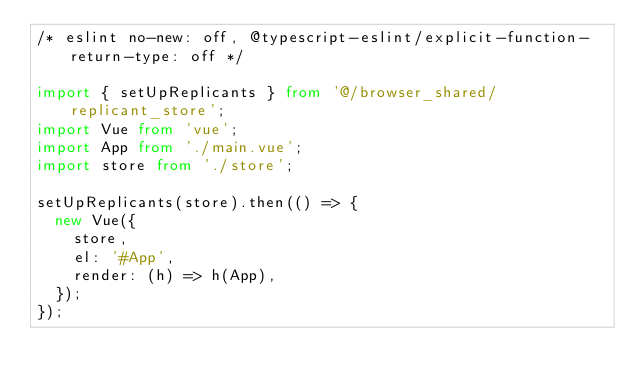Convert code to text. <code><loc_0><loc_0><loc_500><loc_500><_TypeScript_>/* eslint no-new: off, @typescript-eslint/explicit-function-return-type: off */

import { setUpReplicants } from '@/browser_shared/replicant_store';
import Vue from 'vue';
import App from './main.vue';
import store from './store';

setUpReplicants(store).then(() => {
  new Vue({
    store,
    el: '#App',
    render: (h) => h(App),
  });
});
</code> 